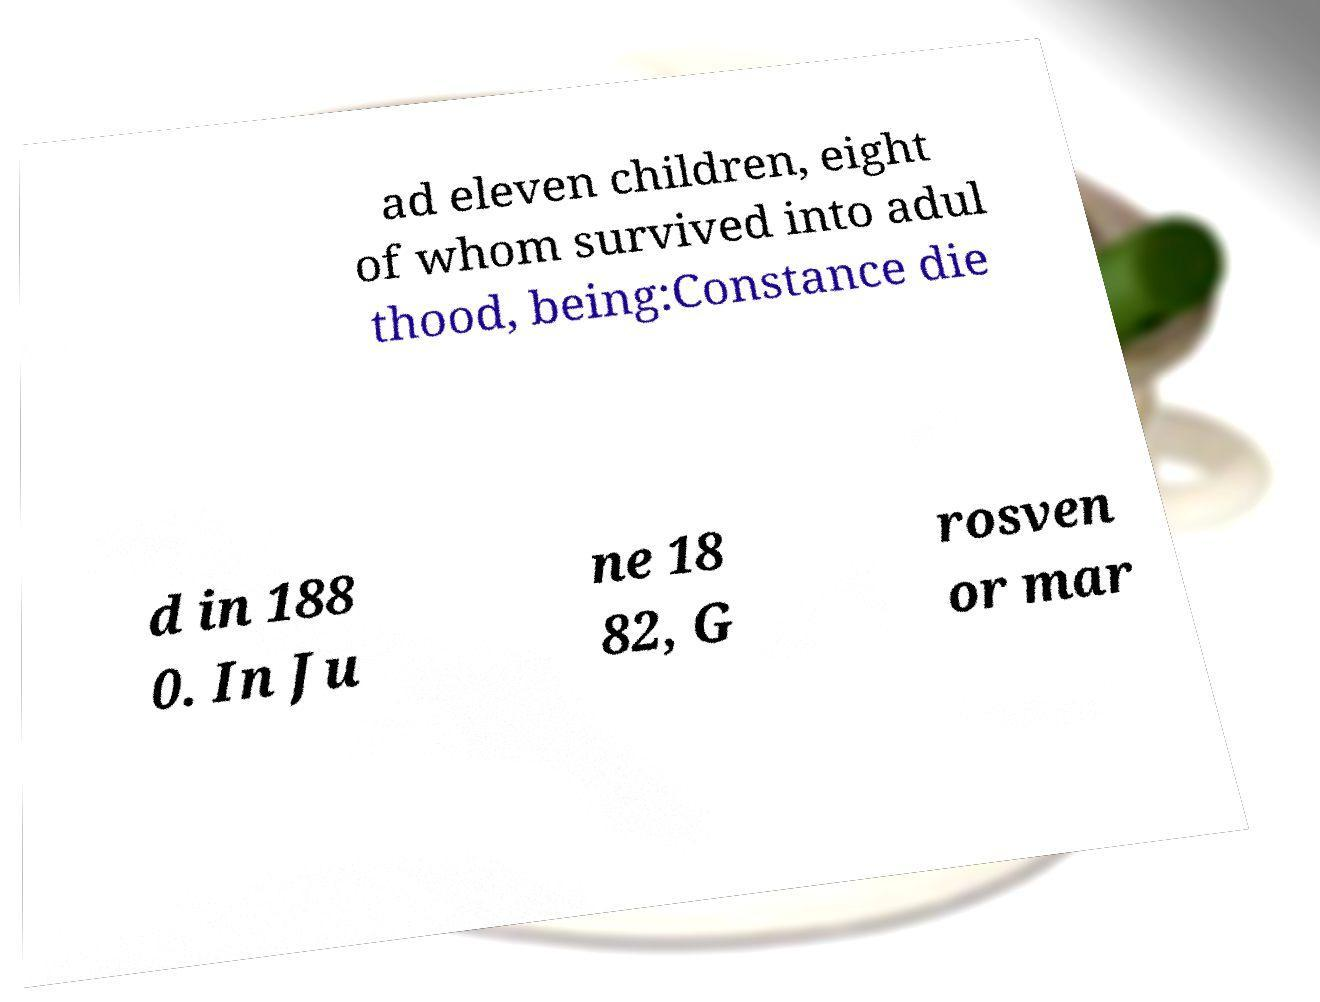Please identify and transcribe the text found in this image. ad eleven children, eight of whom survived into adul thood, being:Constance die d in 188 0. In Ju ne 18 82, G rosven or mar 